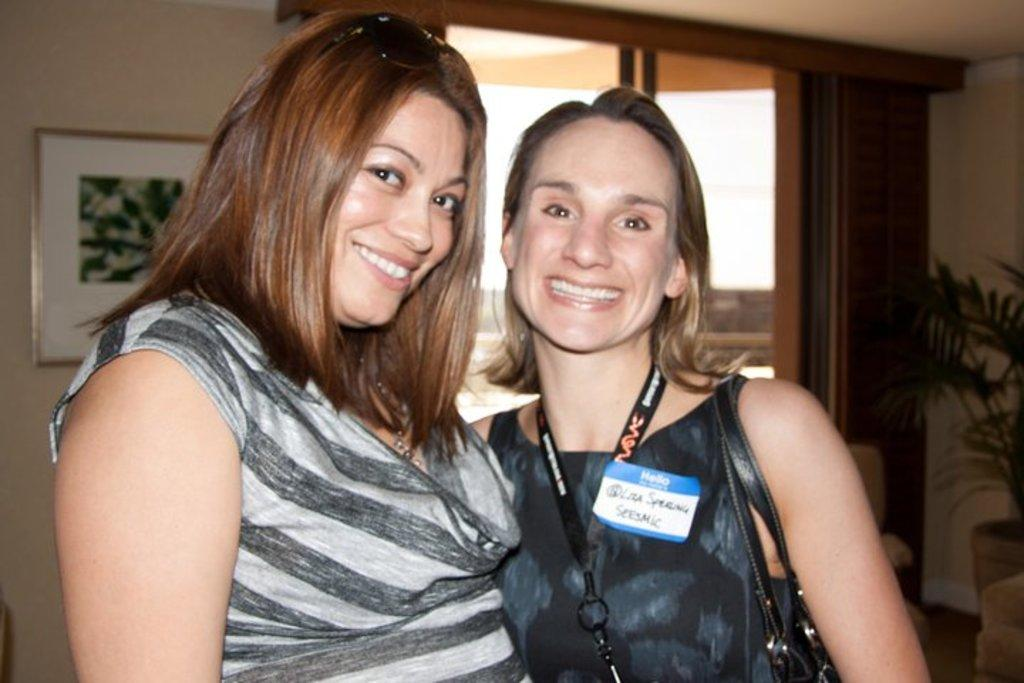How many women are in the image? There are two women in the image. What are the women wearing? Both women are wearing dresses. What are the women doing in the image? The women are standing. Can you describe any accessories the women are carrying? One of the women is carrying a bag. What can be seen in the background of the image? There is a photo frame on the wall, a plant, and a window in the background. What type of dogs can be seen playing with a fan in the image? There are no dogs or fans present in the image. 